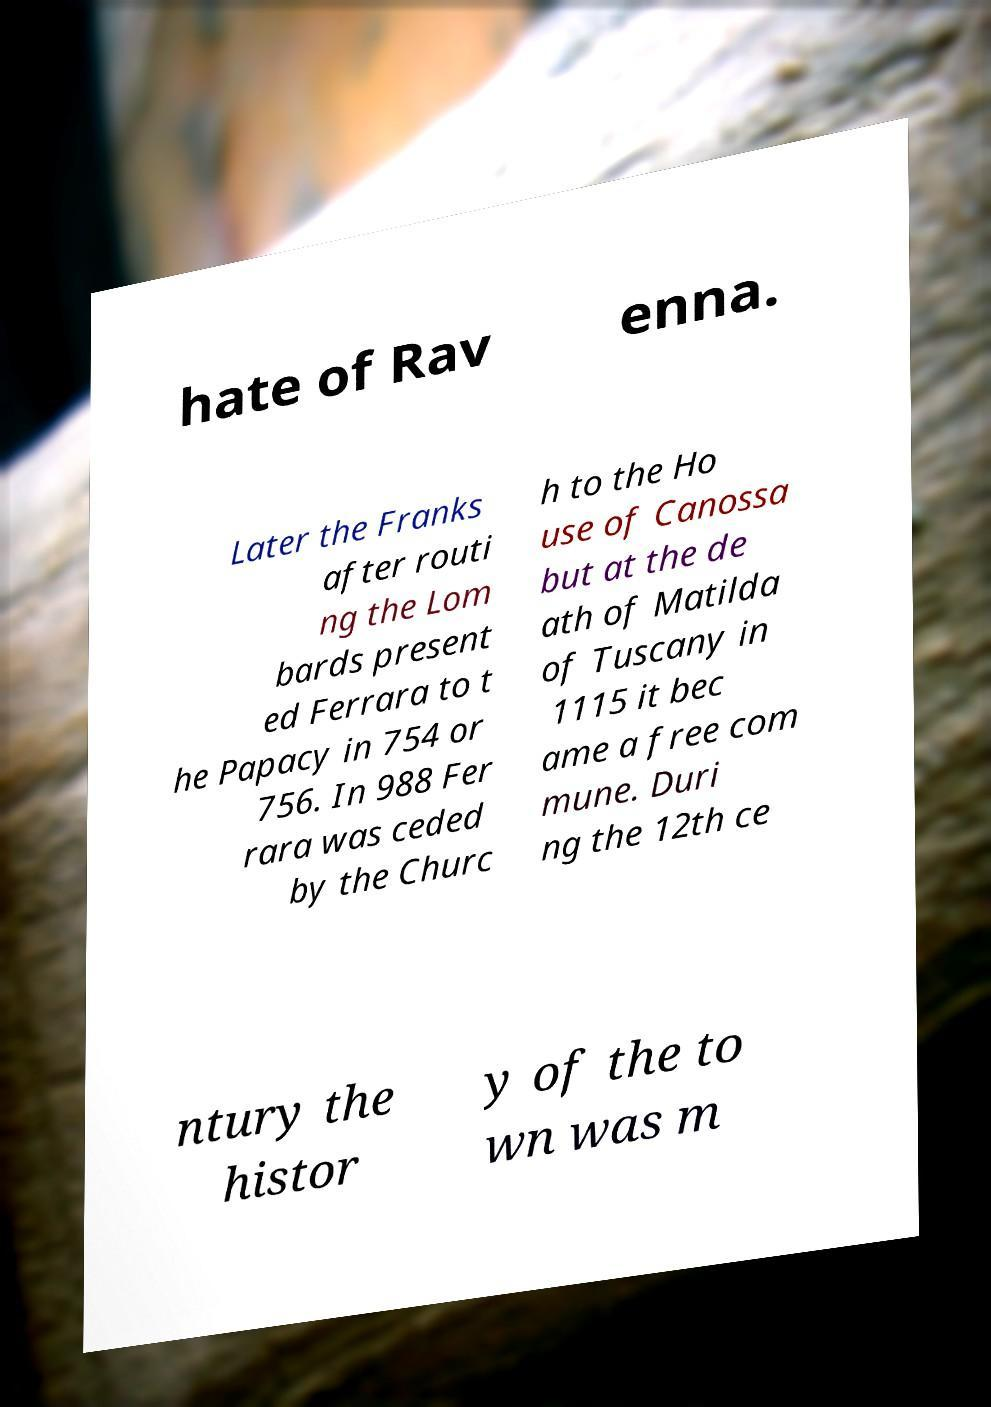What messages or text are displayed in this image? I need them in a readable, typed format. hate of Rav enna. Later the Franks after routi ng the Lom bards present ed Ferrara to t he Papacy in 754 or 756. In 988 Fer rara was ceded by the Churc h to the Ho use of Canossa but at the de ath of Matilda of Tuscany in 1115 it bec ame a free com mune. Duri ng the 12th ce ntury the histor y of the to wn was m 